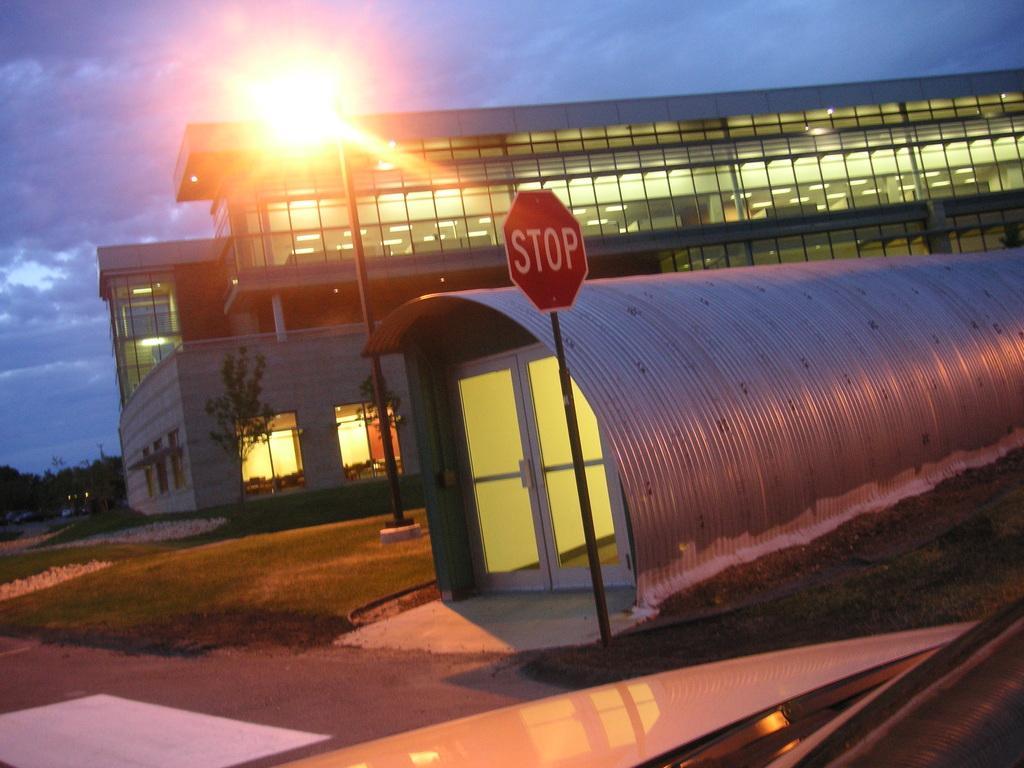<image>
Render a clear and concise summary of the photo. On the corner of a sidewalk a STOP sign is awaits oncoming traffic 